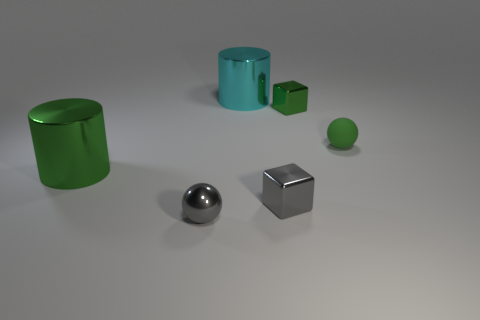What size is the metal cylinder that is behind the green thing that is behind the green sphere?
Provide a short and direct response. Large. Does the rubber thing have the same color as the block that is in front of the small green shiny object?
Your response must be concise. No. Is the number of large cylinders that are in front of the small gray shiny sphere less than the number of tiny cyan rubber cubes?
Offer a very short reply. No. How many other things are the same size as the cyan cylinder?
Make the answer very short. 1. There is a tiny object on the left side of the cyan metal thing; does it have the same shape as the small green matte object?
Offer a very short reply. Yes. Are there more tiny gray things that are on the right side of the green rubber object than cubes?
Provide a short and direct response. No. The tiny thing that is both behind the large green metal object and to the left of the green matte object is made of what material?
Your answer should be compact. Metal. Are there any other things that have the same shape as the rubber object?
Provide a succinct answer. Yes. What number of blocks are behind the matte ball and to the left of the tiny green shiny block?
Offer a very short reply. 0. What is the green sphere made of?
Keep it short and to the point. Rubber. 